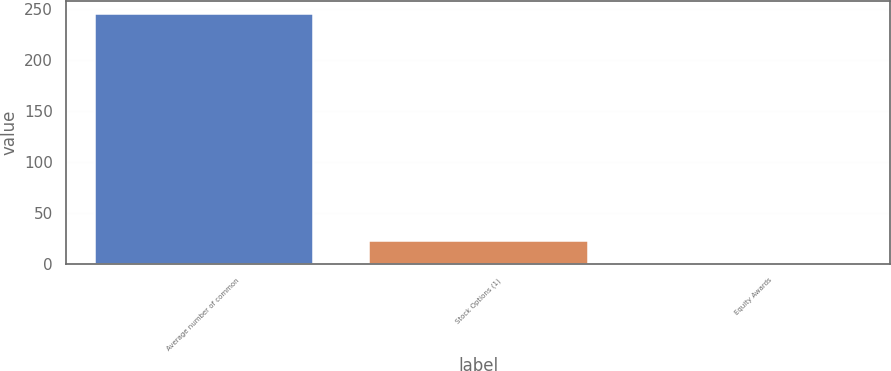Convert chart to OTSL. <chart><loc_0><loc_0><loc_500><loc_500><bar_chart><fcel>Average number of common<fcel>Stock Options (1)<fcel>Equity Awards<nl><fcel>245.69<fcel>23.09<fcel>0.4<nl></chart> 